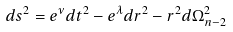Convert formula to latex. <formula><loc_0><loc_0><loc_500><loc_500>d s ^ { 2 } = e ^ { \nu } d t ^ { 2 } - e ^ { \lambda } d r ^ { 2 } - r ^ { 2 } d \Omega _ { n - 2 } ^ { 2 }</formula> 